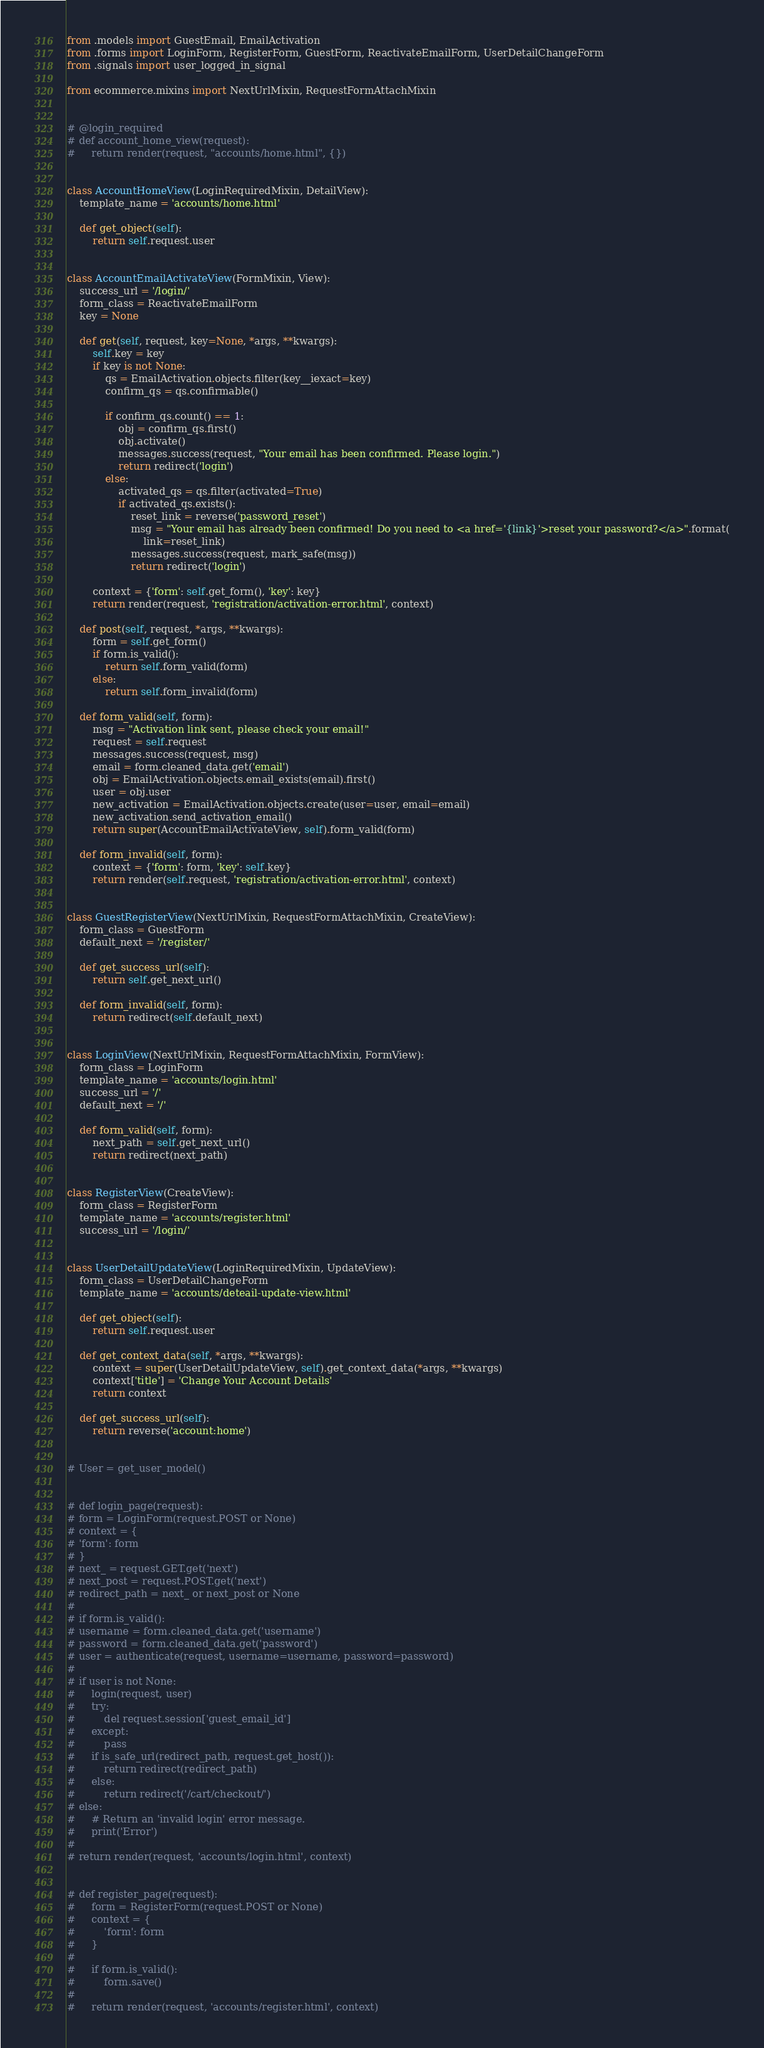<code> <loc_0><loc_0><loc_500><loc_500><_Python_>
from .models import GuestEmail, EmailActivation
from .forms import LoginForm, RegisterForm, GuestForm, ReactivateEmailForm, UserDetailChangeForm
from .signals import user_logged_in_signal

from ecommerce.mixins import NextUrlMixin, RequestFormAttachMixin


# @login_required
# def account_home_view(request):
#     return render(request, "accounts/home.html", {})


class AccountHomeView(LoginRequiredMixin, DetailView):
    template_name = 'accounts/home.html'

    def get_object(self):
        return self.request.user


class AccountEmailActivateView(FormMixin, View):
    success_url = '/login/'
    form_class = ReactivateEmailForm
    key = None

    def get(self, request, key=None, *args, **kwargs):
        self.key = key
        if key is not None:
            qs = EmailActivation.objects.filter(key__iexact=key)
            confirm_qs = qs.confirmable()

            if confirm_qs.count() == 1:
                obj = confirm_qs.first()
                obj.activate()
                messages.success(request, "Your email has been confirmed. Please login.")
                return redirect('login')
            else:
                activated_qs = qs.filter(activated=True)
                if activated_qs.exists():
                    reset_link = reverse('password_reset')
                    msg = "Your email has already been confirmed! Do you need to <a href='{link}'>reset your password?</a>".format(
                        link=reset_link)
                    messages.success(request, mark_safe(msg))
                    return redirect('login')

        context = {'form': self.get_form(), 'key': key}
        return render(request, 'registration/activation-error.html', context)

    def post(self, request, *args, **kwargs):
        form = self.get_form()
        if form.is_valid():
            return self.form_valid(form)
        else:
            return self.form_invalid(form)

    def form_valid(self, form):
        msg = "Activation link sent, please check your email!"
        request = self.request
        messages.success(request, msg)
        email = form.cleaned_data.get('email')
        obj = EmailActivation.objects.email_exists(email).first()
        user = obj.user
        new_activation = EmailActivation.objects.create(user=user, email=email)
        new_activation.send_activation_email()
        return super(AccountEmailActivateView, self).form_valid(form)

    def form_invalid(self, form):
        context = {'form': form, 'key': self.key}
        return render(self.request, 'registration/activation-error.html', context)


class GuestRegisterView(NextUrlMixin, RequestFormAttachMixin, CreateView):
    form_class = GuestForm
    default_next = '/register/'

    def get_success_url(self):
        return self.get_next_url()

    def form_invalid(self, form):
        return redirect(self.default_next)


class LoginView(NextUrlMixin, RequestFormAttachMixin, FormView):
    form_class = LoginForm
    template_name = 'accounts/login.html'
    success_url = '/'
    default_next = '/'

    def form_valid(self, form):
        next_path = self.get_next_url()
        return redirect(next_path)


class RegisterView(CreateView):
    form_class = RegisterForm
    template_name = 'accounts/register.html'
    success_url = '/login/'


class UserDetailUpdateView(LoginRequiredMixin, UpdateView):
    form_class = UserDetailChangeForm
    template_name = 'accounts/deteail-update-view.html'

    def get_object(self):
        return self.request.user

    def get_context_data(self, *args, **kwargs):
        context = super(UserDetailUpdateView, self).get_context_data(*args, **kwargs)
        context['title'] = 'Change Your Account Details'
        return context

    def get_success_url(self):
        return reverse('account:home')


# User = get_user_model()


# def login_page(request):
# form = LoginForm(request.POST or None)
# context = {
# 'form': form
# }
# next_ = request.GET.get('next')
# next_post = request.POST.get('next')
# redirect_path = next_ or next_post or None
#
# if form.is_valid():
# username = form.cleaned_data.get('username')
# password = form.cleaned_data.get('password')
# user = authenticate(request, username=username, password=password)
#
# if user is not None:
#     login(request, user)
#     try:
#         del request.session['guest_email_id']
#     except:
#         pass
#     if is_safe_url(redirect_path, request.get_host()):
#         return redirect(redirect_path)
#     else:
#         return redirect('/cart/checkout/')
# else:
#     # Return an 'invalid login' error message.
#     print('Error')
#
# return render(request, 'accounts/login.html', context)


# def register_page(request):
#     form = RegisterForm(request.POST or None)
#     context = {
#         'form': form
#     }
#
#     if form.is_valid():
#         form.save()
#
#     return render(request, 'accounts/register.html', context)
</code> 